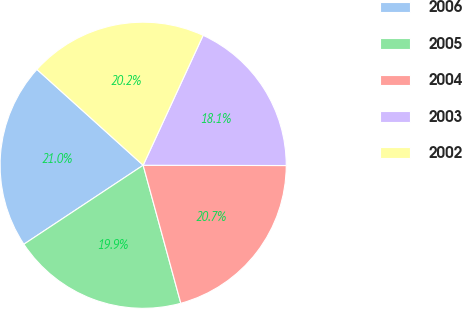<chart> <loc_0><loc_0><loc_500><loc_500><pie_chart><fcel>2006<fcel>2005<fcel>2004<fcel>2003<fcel>2002<nl><fcel>20.99%<fcel>19.93%<fcel>20.73%<fcel>18.15%<fcel>20.2%<nl></chart> 